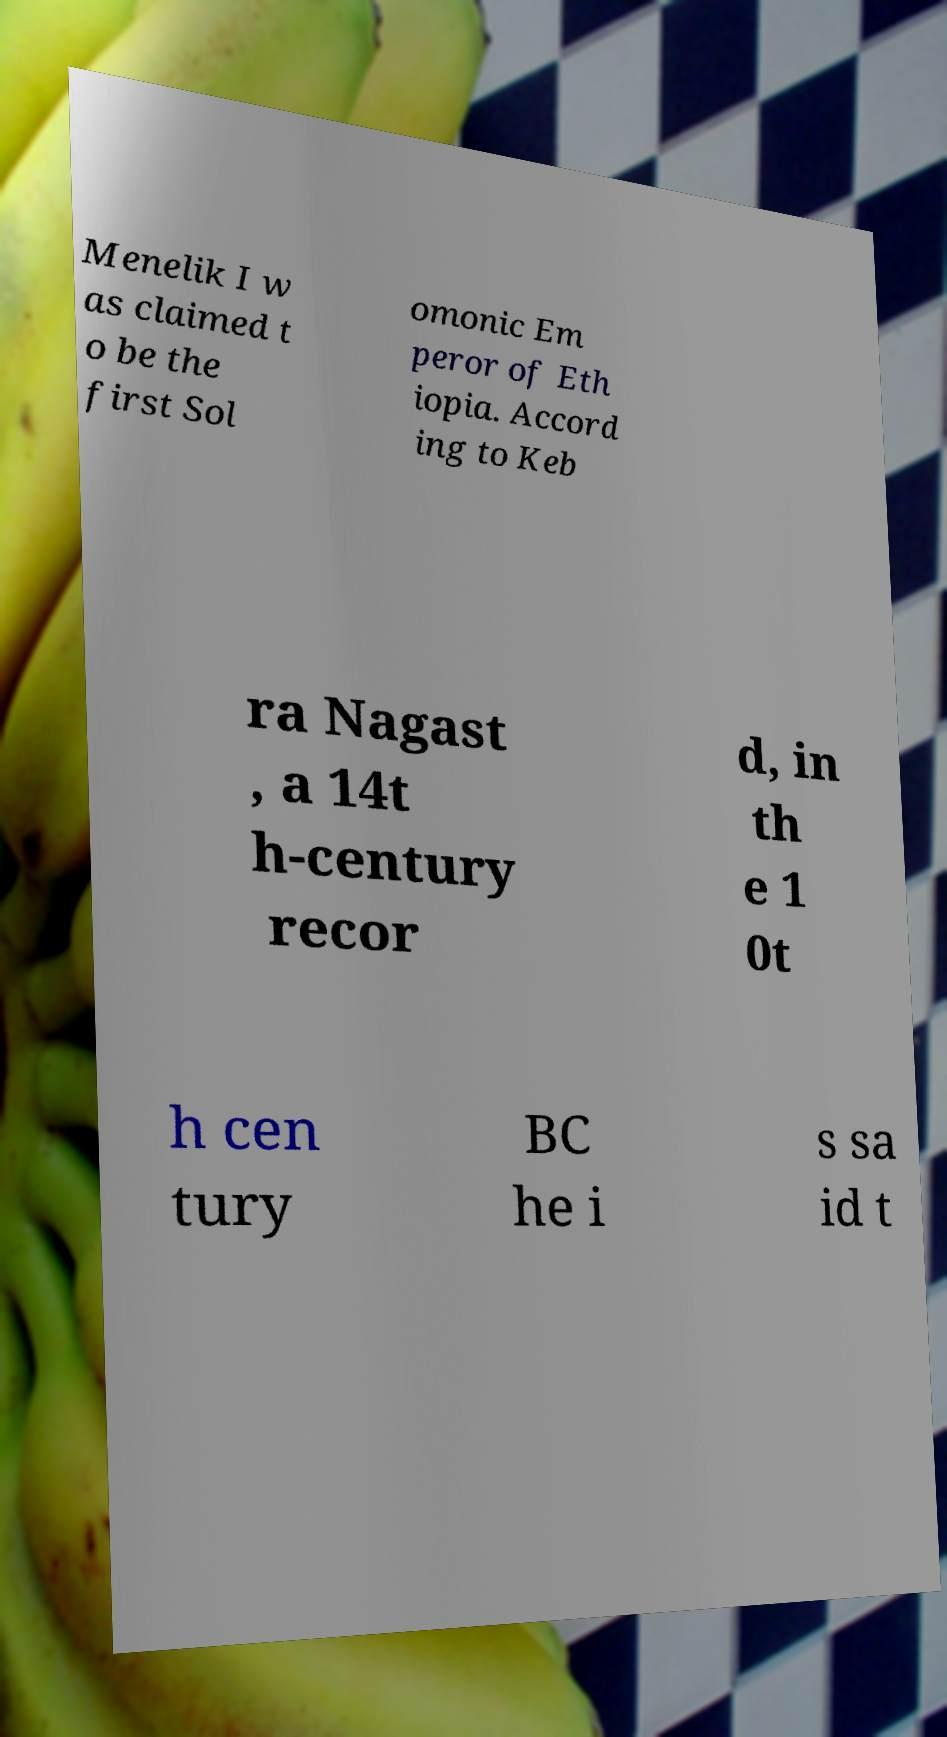Could you assist in decoding the text presented in this image and type it out clearly? Menelik I w as claimed t o be the first Sol omonic Em peror of Eth iopia. Accord ing to Keb ra Nagast , a 14t h-century recor d, in th e 1 0t h cen tury BC he i s sa id t 